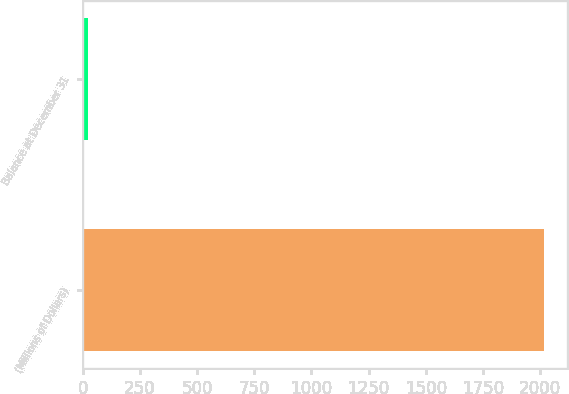<chart> <loc_0><loc_0><loc_500><loc_500><bar_chart><fcel>(Millions of Dollars)<fcel>Balance at December 31<nl><fcel>2016<fcel>21<nl></chart> 